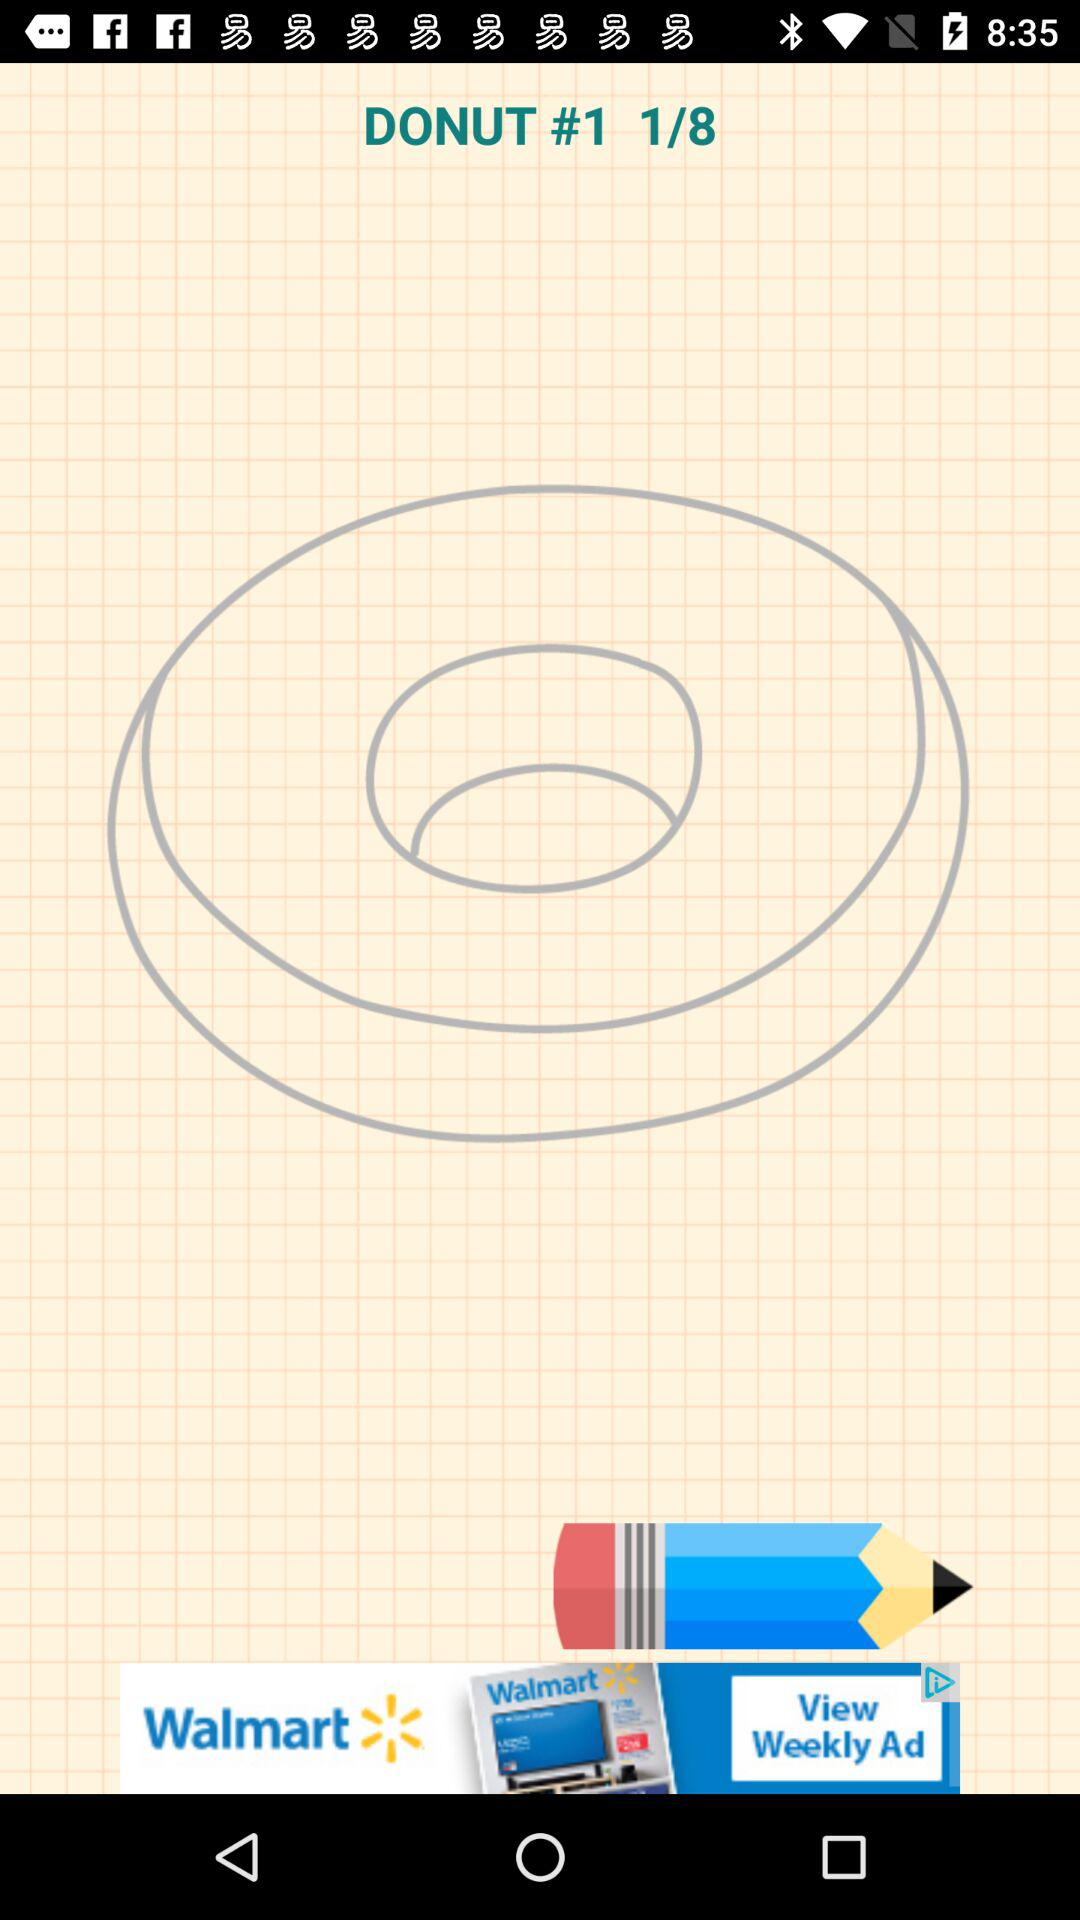How many pages in total are there? There are 8 pages in total. 